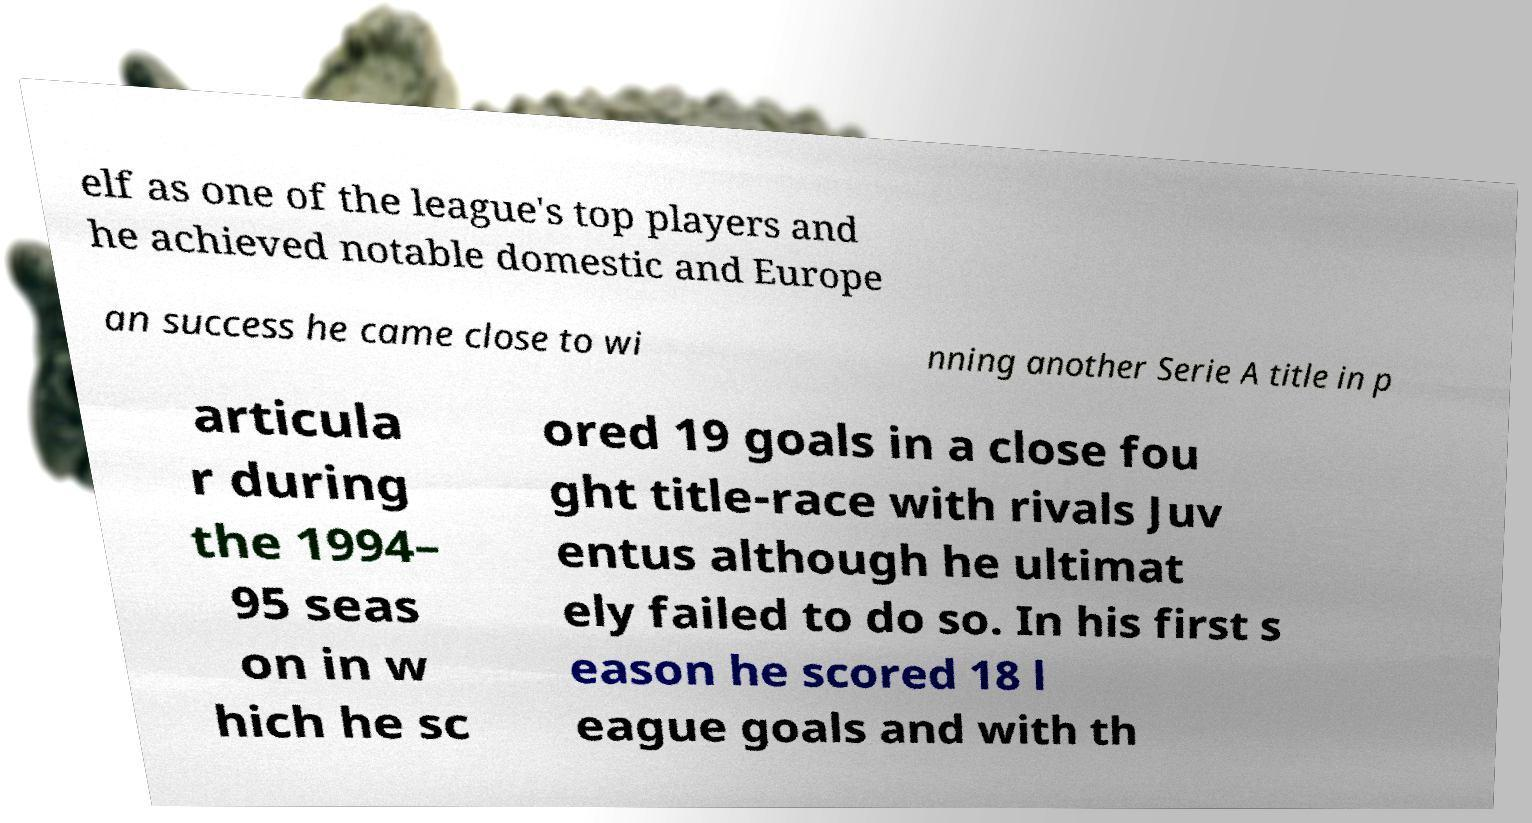Could you assist in decoding the text presented in this image and type it out clearly? elf as one of the league's top players and he achieved notable domestic and Europe an success he came close to wi nning another Serie A title in p articula r during the 1994– 95 seas on in w hich he sc ored 19 goals in a close fou ght title-race with rivals Juv entus although he ultimat ely failed to do so. In his first s eason he scored 18 l eague goals and with th 